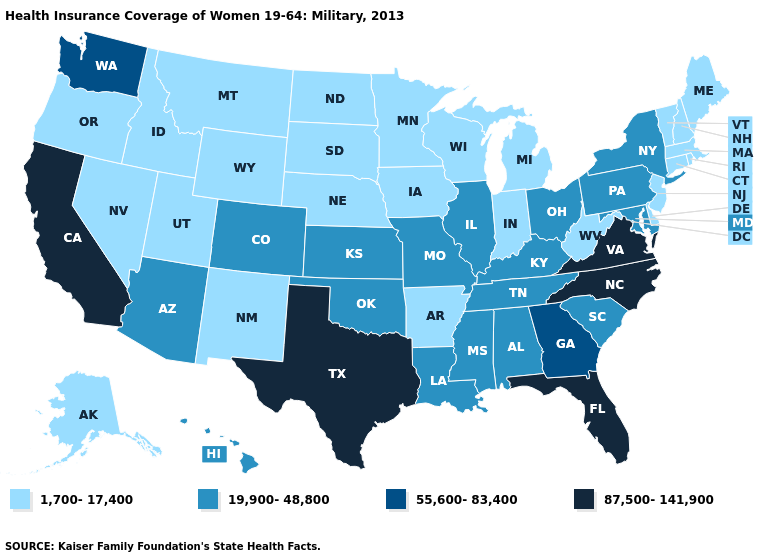Does Hawaii have the lowest value in the West?
Keep it brief. No. Which states have the highest value in the USA?
Be succinct. California, Florida, North Carolina, Texas, Virginia. Among the states that border New York , does Pennsylvania have the lowest value?
Concise answer only. No. Name the states that have a value in the range 19,900-48,800?
Keep it brief. Alabama, Arizona, Colorado, Hawaii, Illinois, Kansas, Kentucky, Louisiana, Maryland, Mississippi, Missouri, New York, Ohio, Oklahoma, Pennsylvania, South Carolina, Tennessee. Name the states that have a value in the range 87,500-141,900?
Concise answer only. California, Florida, North Carolina, Texas, Virginia. What is the value of Arkansas?
Give a very brief answer. 1,700-17,400. What is the value of Missouri?
Give a very brief answer. 19,900-48,800. Which states have the highest value in the USA?
Be succinct. California, Florida, North Carolina, Texas, Virginia. What is the value of Colorado?
Write a very short answer. 19,900-48,800. Does Virginia have the highest value in the USA?
Give a very brief answer. Yes. What is the lowest value in the USA?
Give a very brief answer. 1,700-17,400. Name the states that have a value in the range 87,500-141,900?
Concise answer only. California, Florida, North Carolina, Texas, Virginia. What is the value of Arkansas?
Quick response, please. 1,700-17,400. What is the highest value in states that border Michigan?
Answer briefly. 19,900-48,800. What is the lowest value in the USA?
Concise answer only. 1,700-17,400. 